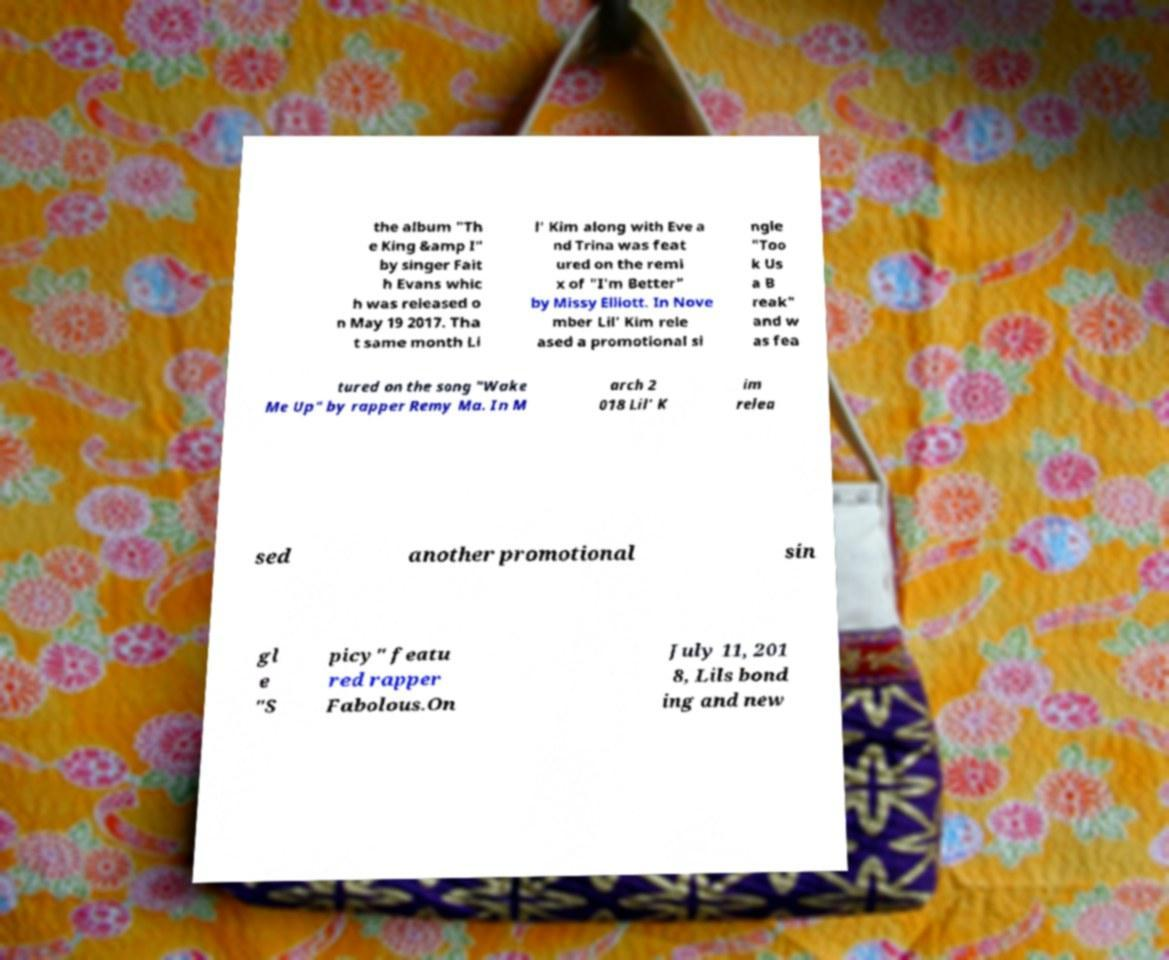Can you read and provide the text displayed in the image?This photo seems to have some interesting text. Can you extract and type it out for me? the album "Th e King &amp I" by singer Fait h Evans whic h was released o n May 19 2017. Tha t same month Li l' Kim along with Eve a nd Trina was feat ured on the remi x of "I'm Better" by Missy Elliott. In Nove mber Lil' Kim rele ased a promotional si ngle "Too k Us a B reak" and w as fea tured on the song "Wake Me Up" by rapper Remy Ma. In M arch 2 018 Lil' K im relea sed another promotional sin gl e "S picy" featu red rapper Fabolous.On July 11, 201 8, Lils bond ing and new 